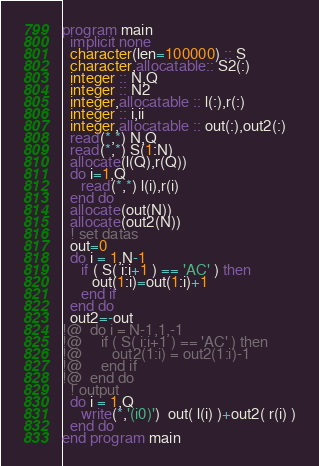Convert code to text. <code><loc_0><loc_0><loc_500><loc_500><_FORTRAN_>program main
  implicit none
  character(len=100000) :: S
  character,allocatable:: S2(:)
  integer :: N,Q
  integer :: N2
  integer,allocatable :: l(:),r(:)
  integer :: i,ii
  integer,allocatable :: out(:),out2(:)
  read(*,*) N,Q
  read(*,*) S(1:N)
  allocate(l(Q),r(Q))
  do i=1,Q
     read(*,*) l(i),r(i)
  end do
  allocate(out(N))
  allocate(out2(N))
  ! set datas 
  out=0
  do i = 1,N-1
     if ( S( i:i+1 ) == 'AC' ) then
        out(1:i)=out(1:i)+1
     end if
  end do
  out2=-out
!@  do i = N-1,1,-1
!@     if ( S( i:i+1 ) == 'AC' ) then
!@        out2(1:i) = out2(1:i)-1
!@     end if
!@  end do
  ! output
  do i = 1,Q
     write(*,'(i0)')  out( l(i) )+out2( r(i) )
  end do
end program main
</code> 